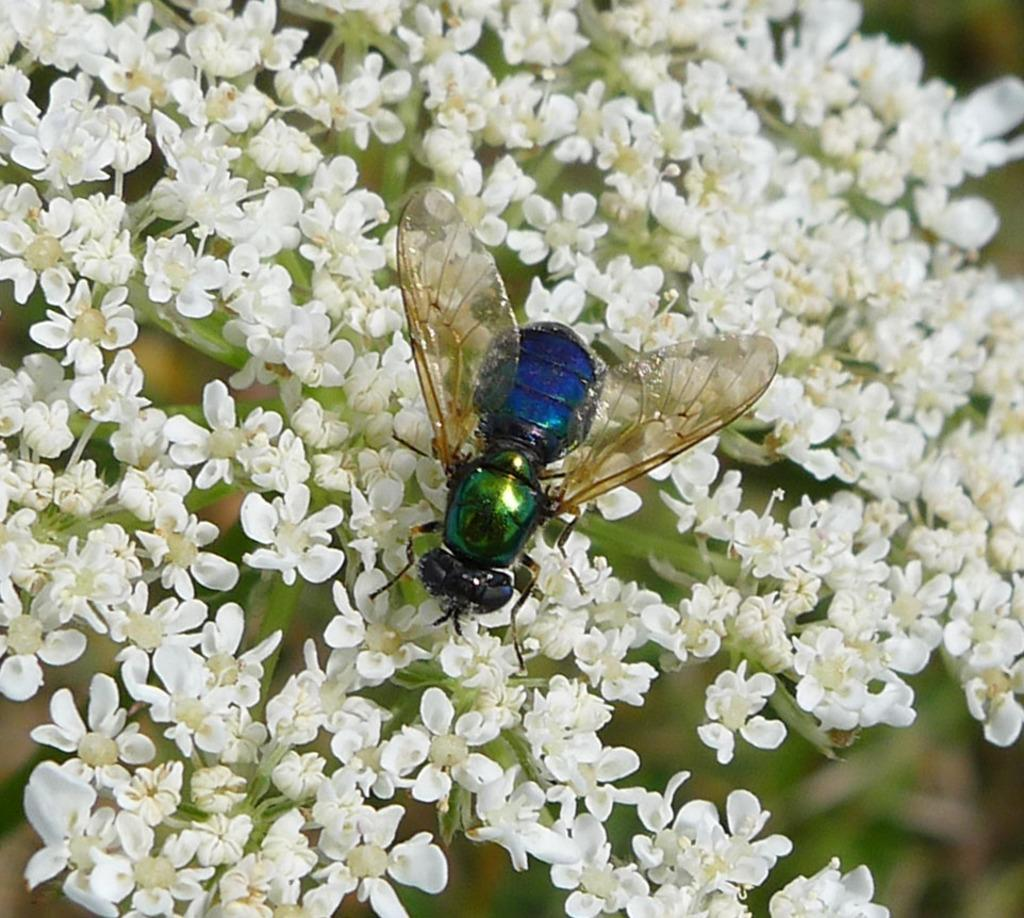What type of flora is present in the image? There is a group of flowers in the image. What color are the flowers? The flowers are white in color. Are there any insects visible in the image? Yes, there is a house fly in the image. What are the main features of the house fly? The house fly has wings and its body has green and blue colors. What type of apparatus is used to tighten the screws on the flowers in the image? There is no apparatus or screws present in the image; it features a group of white flowers and a house fly. 